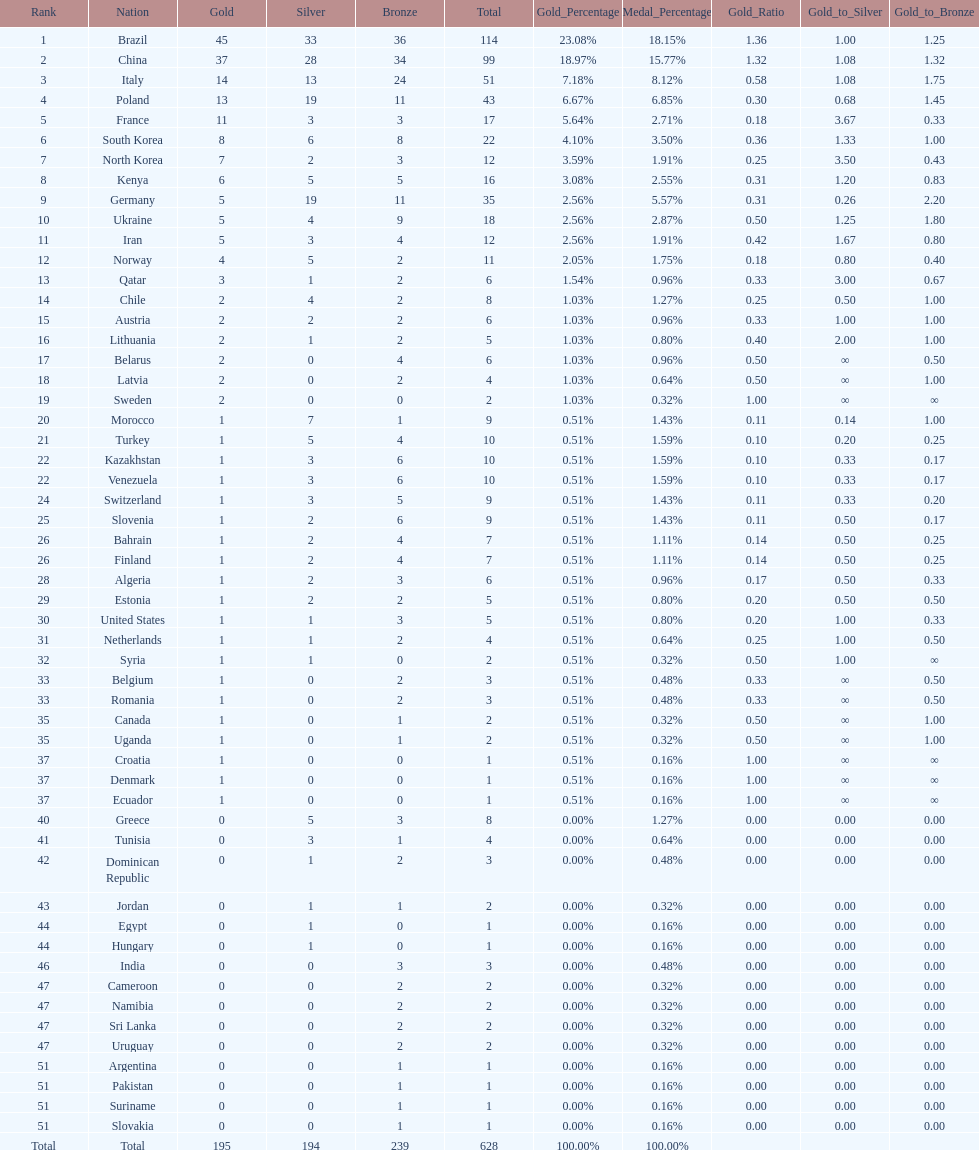South korea has how many more medals that north korea? 10. 